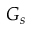<formula> <loc_0><loc_0><loc_500><loc_500>G _ { s }</formula> 